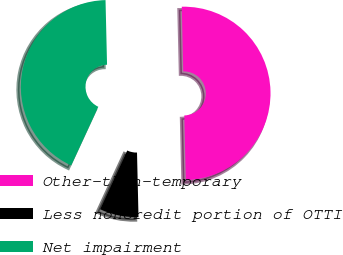Convert chart to OTSL. <chart><loc_0><loc_0><loc_500><loc_500><pie_chart><fcel>Other-than-temporary<fcel>Less noncredit portion of OTTI<fcel>Net impairment<nl><fcel>50.0%<fcel>7.26%<fcel>42.74%<nl></chart> 